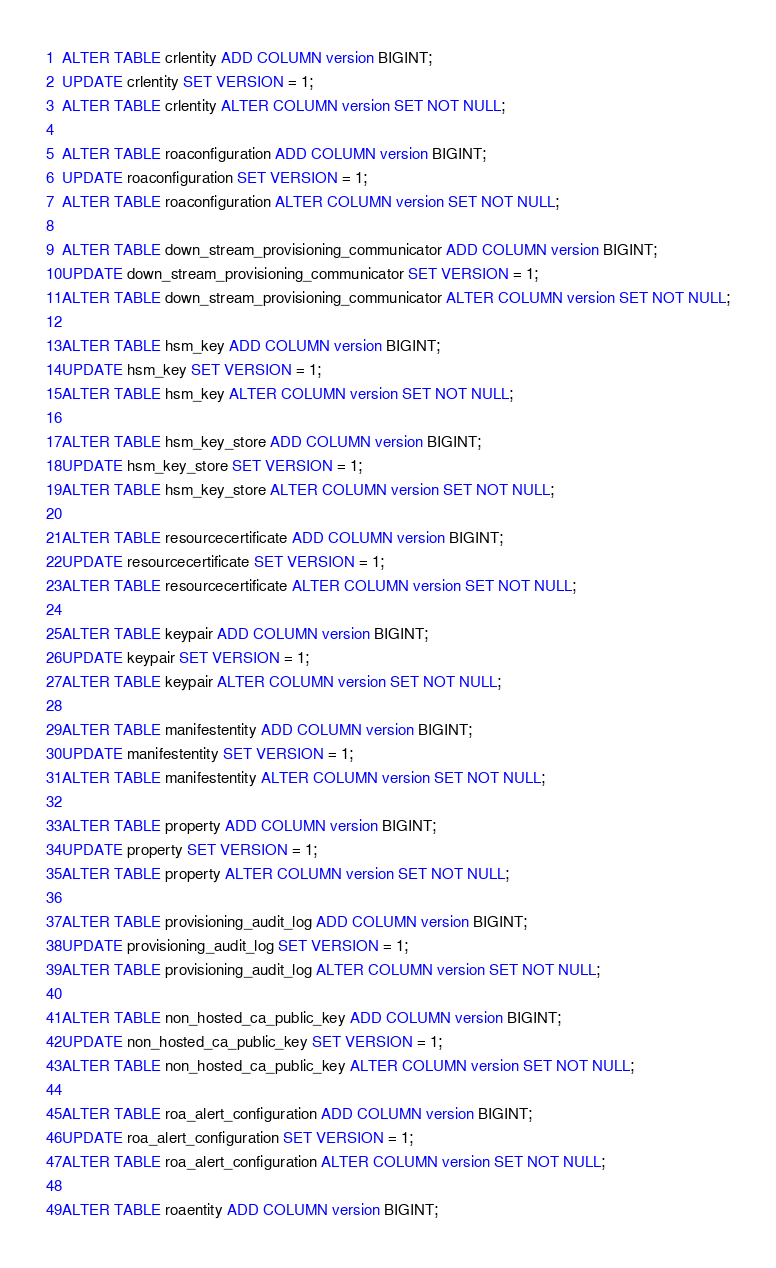Convert code to text. <code><loc_0><loc_0><loc_500><loc_500><_SQL_>ALTER TABLE crlentity ADD COLUMN version BIGINT;
UPDATE crlentity SET VERSION = 1;
ALTER TABLE crlentity ALTER COLUMN version SET NOT NULL;

ALTER TABLE roaconfiguration ADD COLUMN version BIGINT;
UPDATE roaconfiguration SET VERSION = 1;
ALTER TABLE roaconfiguration ALTER COLUMN version SET NOT NULL;

ALTER TABLE down_stream_provisioning_communicator ADD COLUMN version BIGINT;
UPDATE down_stream_provisioning_communicator SET VERSION = 1;
ALTER TABLE down_stream_provisioning_communicator ALTER COLUMN version SET NOT NULL;

ALTER TABLE hsm_key ADD COLUMN version BIGINT;
UPDATE hsm_key SET VERSION = 1;
ALTER TABLE hsm_key ALTER COLUMN version SET NOT NULL;

ALTER TABLE hsm_key_store ADD COLUMN version BIGINT;
UPDATE hsm_key_store SET VERSION = 1;
ALTER TABLE hsm_key_store ALTER COLUMN version SET NOT NULL;

ALTER TABLE resourcecertificate ADD COLUMN version BIGINT;
UPDATE resourcecertificate SET VERSION = 1;
ALTER TABLE resourcecertificate ALTER COLUMN version SET NOT NULL;

ALTER TABLE keypair ADD COLUMN version BIGINT;
UPDATE keypair SET VERSION = 1;
ALTER TABLE keypair ALTER COLUMN version SET NOT NULL;

ALTER TABLE manifestentity ADD COLUMN version BIGINT;
UPDATE manifestentity SET VERSION = 1;
ALTER TABLE manifestentity ALTER COLUMN version SET NOT NULL;

ALTER TABLE property ADD COLUMN version BIGINT;
UPDATE property SET VERSION = 1;
ALTER TABLE property ALTER COLUMN version SET NOT NULL;

ALTER TABLE provisioning_audit_log ADD COLUMN version BIGINT;
UPDATE provisioning_audit_log SET VERSION = 1;
ALTER TABLE provisioning_audit_log ALTER COLUMN version SET NOT NULL;

ALTER TABLE non_hosted_ca_public_key ADD COLUMN version BIGINT;
UPDATE non_hosted_ca_public_key SET VERSION = 1;
ALTER TABLE non_hosted_ca_public_key ALTER COLUMN version SET NOT NULL;

ALTER TABLE roa_alert_configuration ADD COLUMN version BIGINT;
UPDATE roa_alert_configuration SET VERSION = 1;
ALTER TABLE roa_alert_configuration ALTER COLUMN version SET NOT NULL;

ALTER TABLE roaentity ADD COLUMN version BIGINT;</code> 